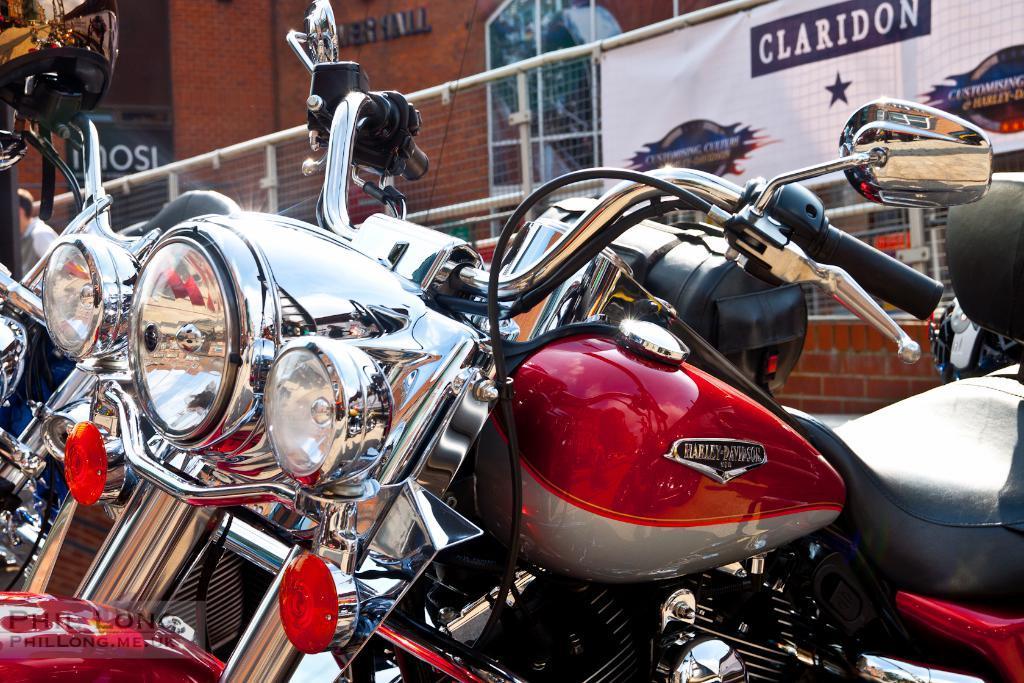Please provide a concise description of this image. In the image there are few vehicles parked one beside another in front of showroom, all the vehicles are new and sealed one. 